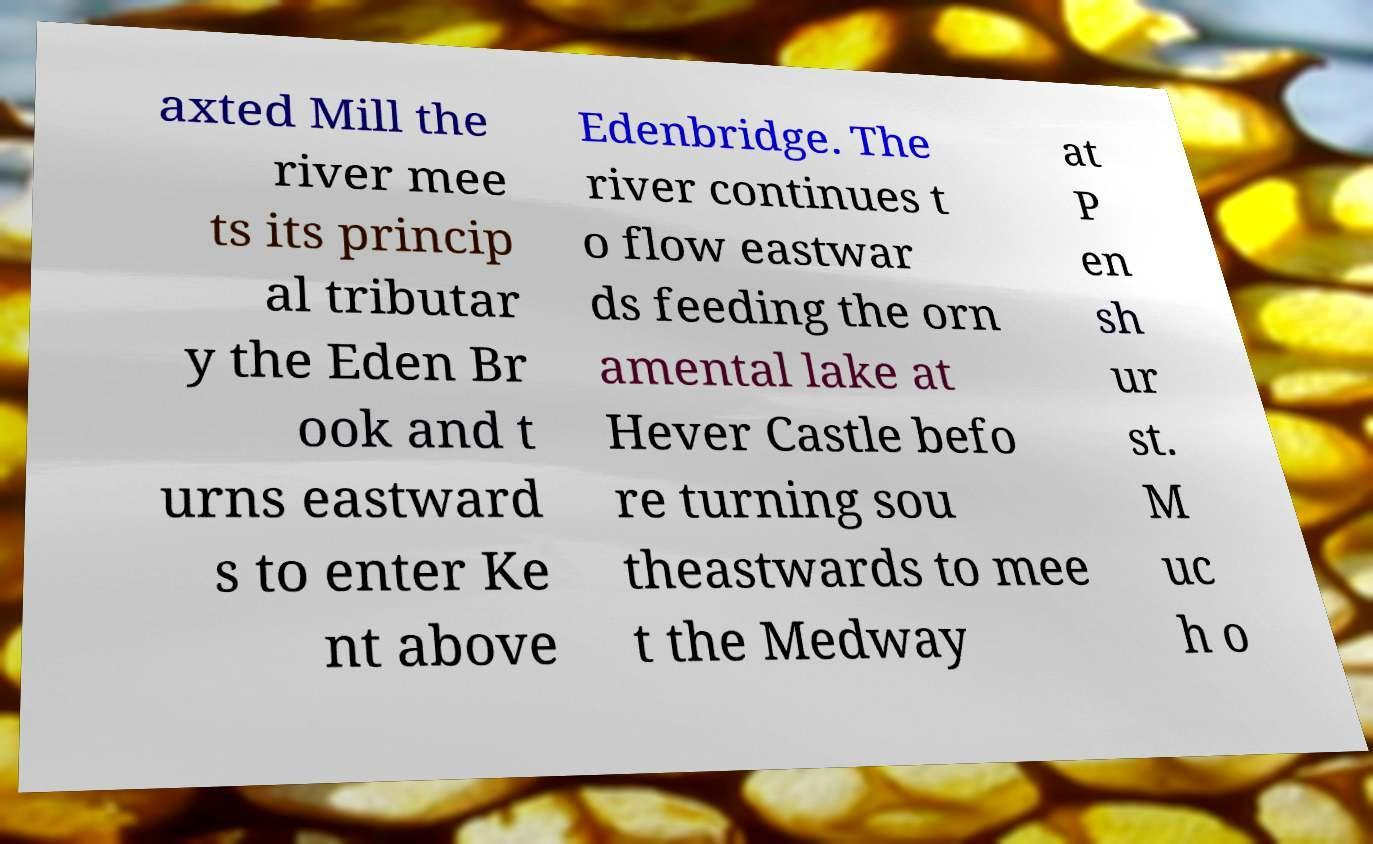What messages or text are displayed in this image? I need them in a readable, typed format. axted Mill the river mee ts its princip al tributar y the Eden Br ook and t urns eastward s to enter Ke nt above Edenbridge. The river continues t o flow eastwar ds feeding the orn amental lake at Hever Castle befo re turning sou theastwards to mee t the Medway at P en sh ur st. M uc h o 